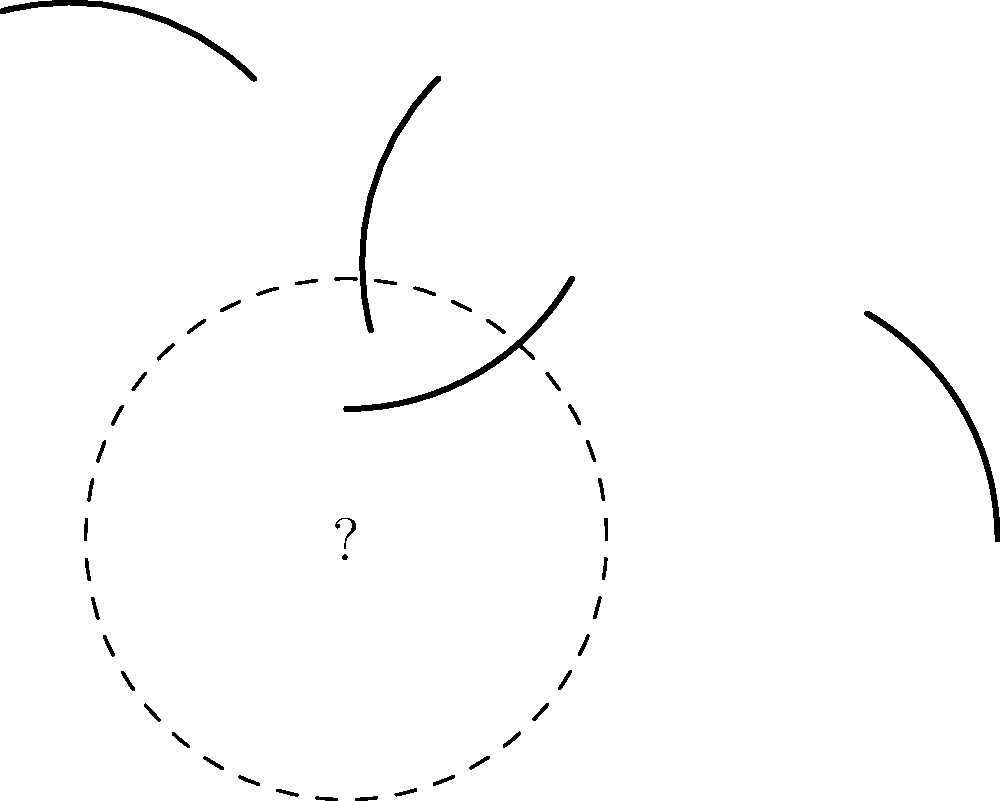Given the scattered pottery fragments shown in the diagram, how many degrees of the original circular vessel's circumference are missing? To solve this problem, we need to follow these steps:

1. Observe that the original vessel was circular, as indicated by the dashed outline.
2. Count the number of fragments: there are 4 distinct pieces.
3. Measure the arc length of each fragment:
   - Each fragment spans 60° of the circle's circumference.
4. Calculate the total arc length covered by the fragments:
   - Total covered = $4 \times 60° = 240°$
5. Recall that a full circle has 360°.
6. Calculate the missing portion:
   - Missing degrees = $360° - 240° = 120°$

Therefore, 120° of the original vessel's circumference are missing.
Answer: 120° 